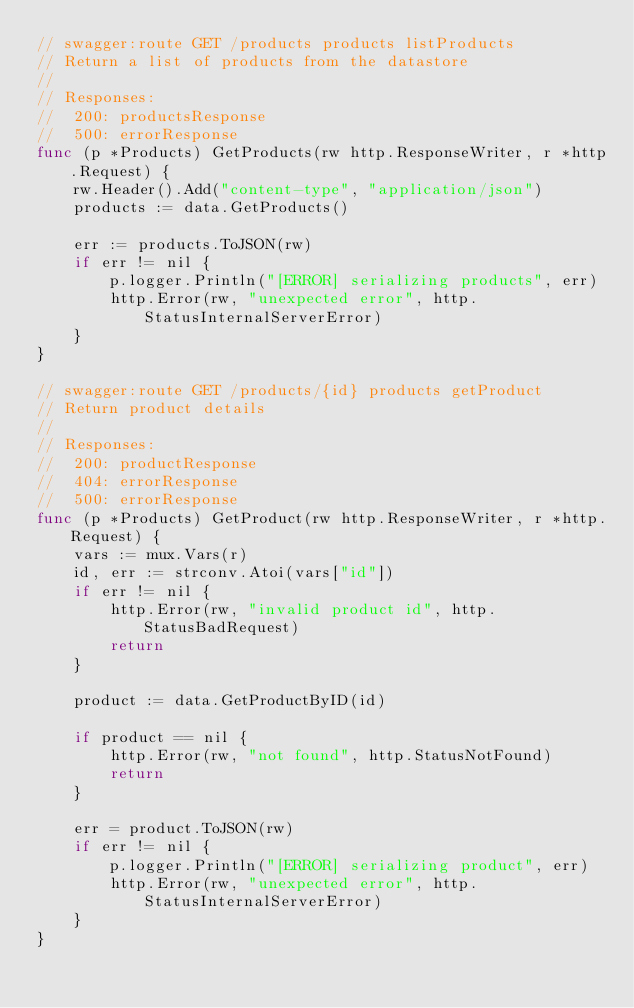Convert code to text. <code><loc_0><loc_0><loc_500><loc_500><_Go_>// swagger:route GET /products products listProducts
// Return a list of products from the datastore
//
// Responses:
// 	200: productsResponse
//  500: errorResponse
func (p *Products) GetProducts(rw http.ResponseWriter, r *http.Request) {
	rw.Header().Add("content-type", "application/json")
	products := data.GetProducts()

	err := products.ToJSON(rw)
	if err != nil {
		p.logger.Println("[ERROR] serializing products", err)
		http.Error(rw, "unexpected error", http.StatusInternalServerError)
	}
}

// swagger:route GET /products/{id} products getProduct
// Return product details
//
// Responses:
// 	200: productResponse
//	404: errorResponse
//	500: errorResponse
func (p *Products) GetProduct(rw http.ResponseWriter, r *http.Request) {
	vars := mux.Vars(r)
	id, err := strconv.Atoi(vars["id"])
	if err != nil {
		http.Error(rw, "invalid product id", http.StatusBadRequest)
		return
	}

	product := data.GetProductByID(id)

	if product == nil {
		http.Error(rw, "not found", http.StatusNotFound)
		return
	}

	err = product.ToJSON(rw)
	if err != nil {
		p.logger.Println("[ERROR] serializing product", err)
		http.Error(rw, "unexpected error", http.StatusInternalServerError)
	}
}
</code> 